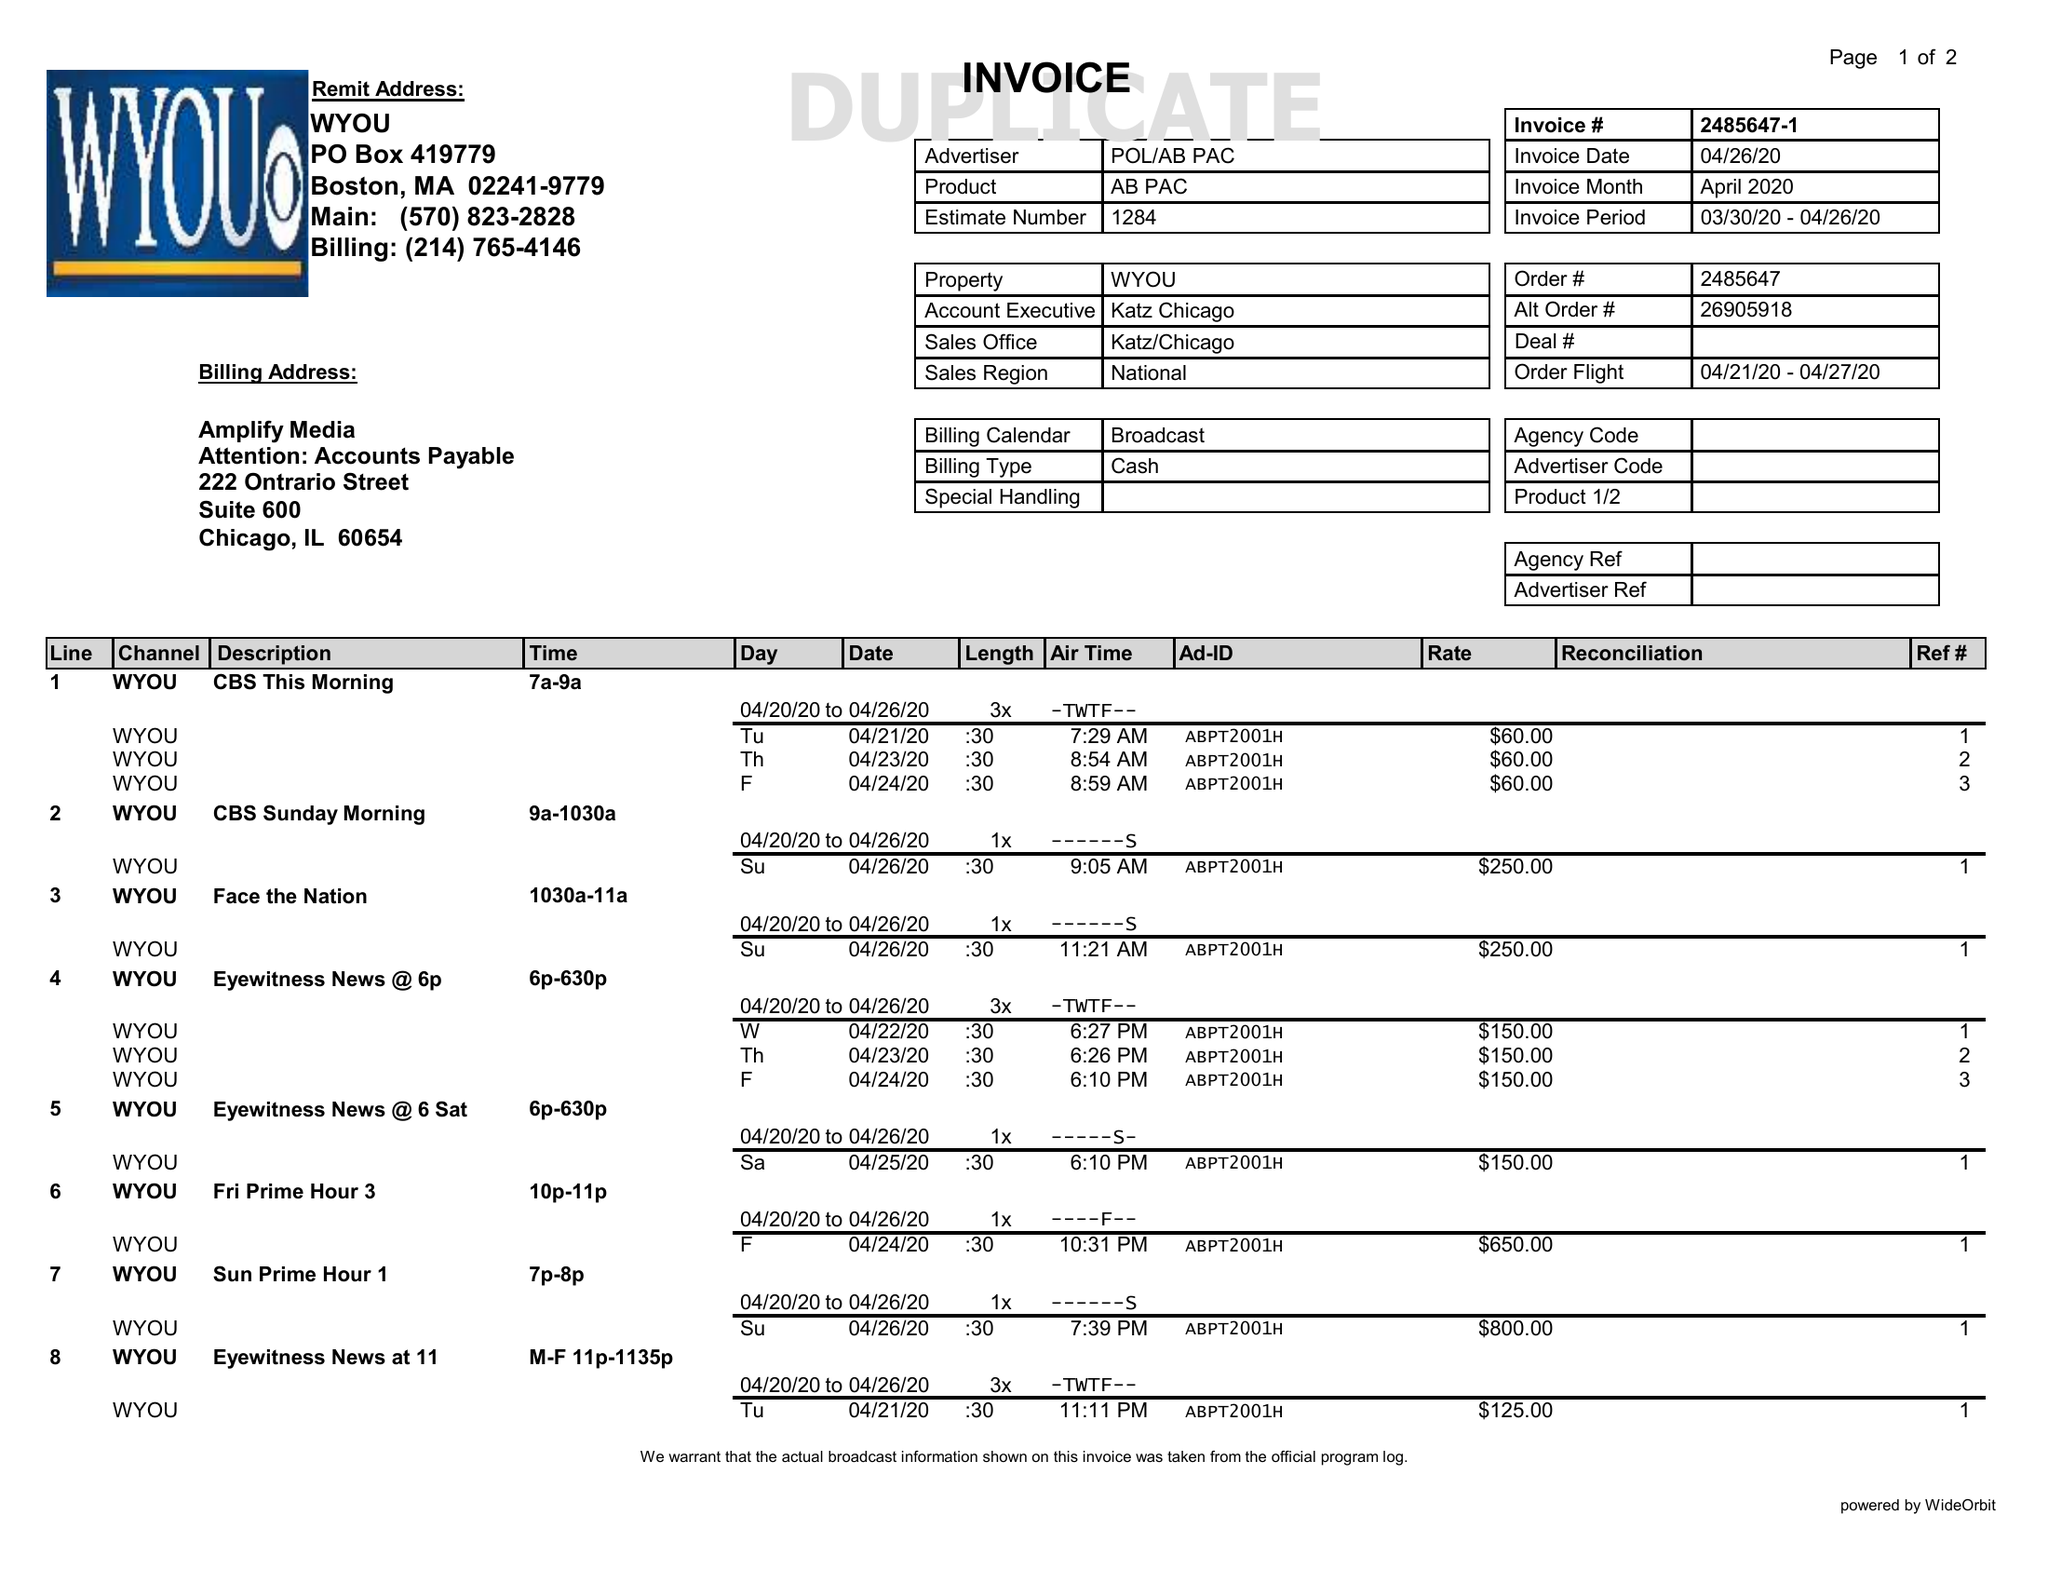What is the value for the flight_from?
Answer the question using a single word or phrase. 04/21/20 